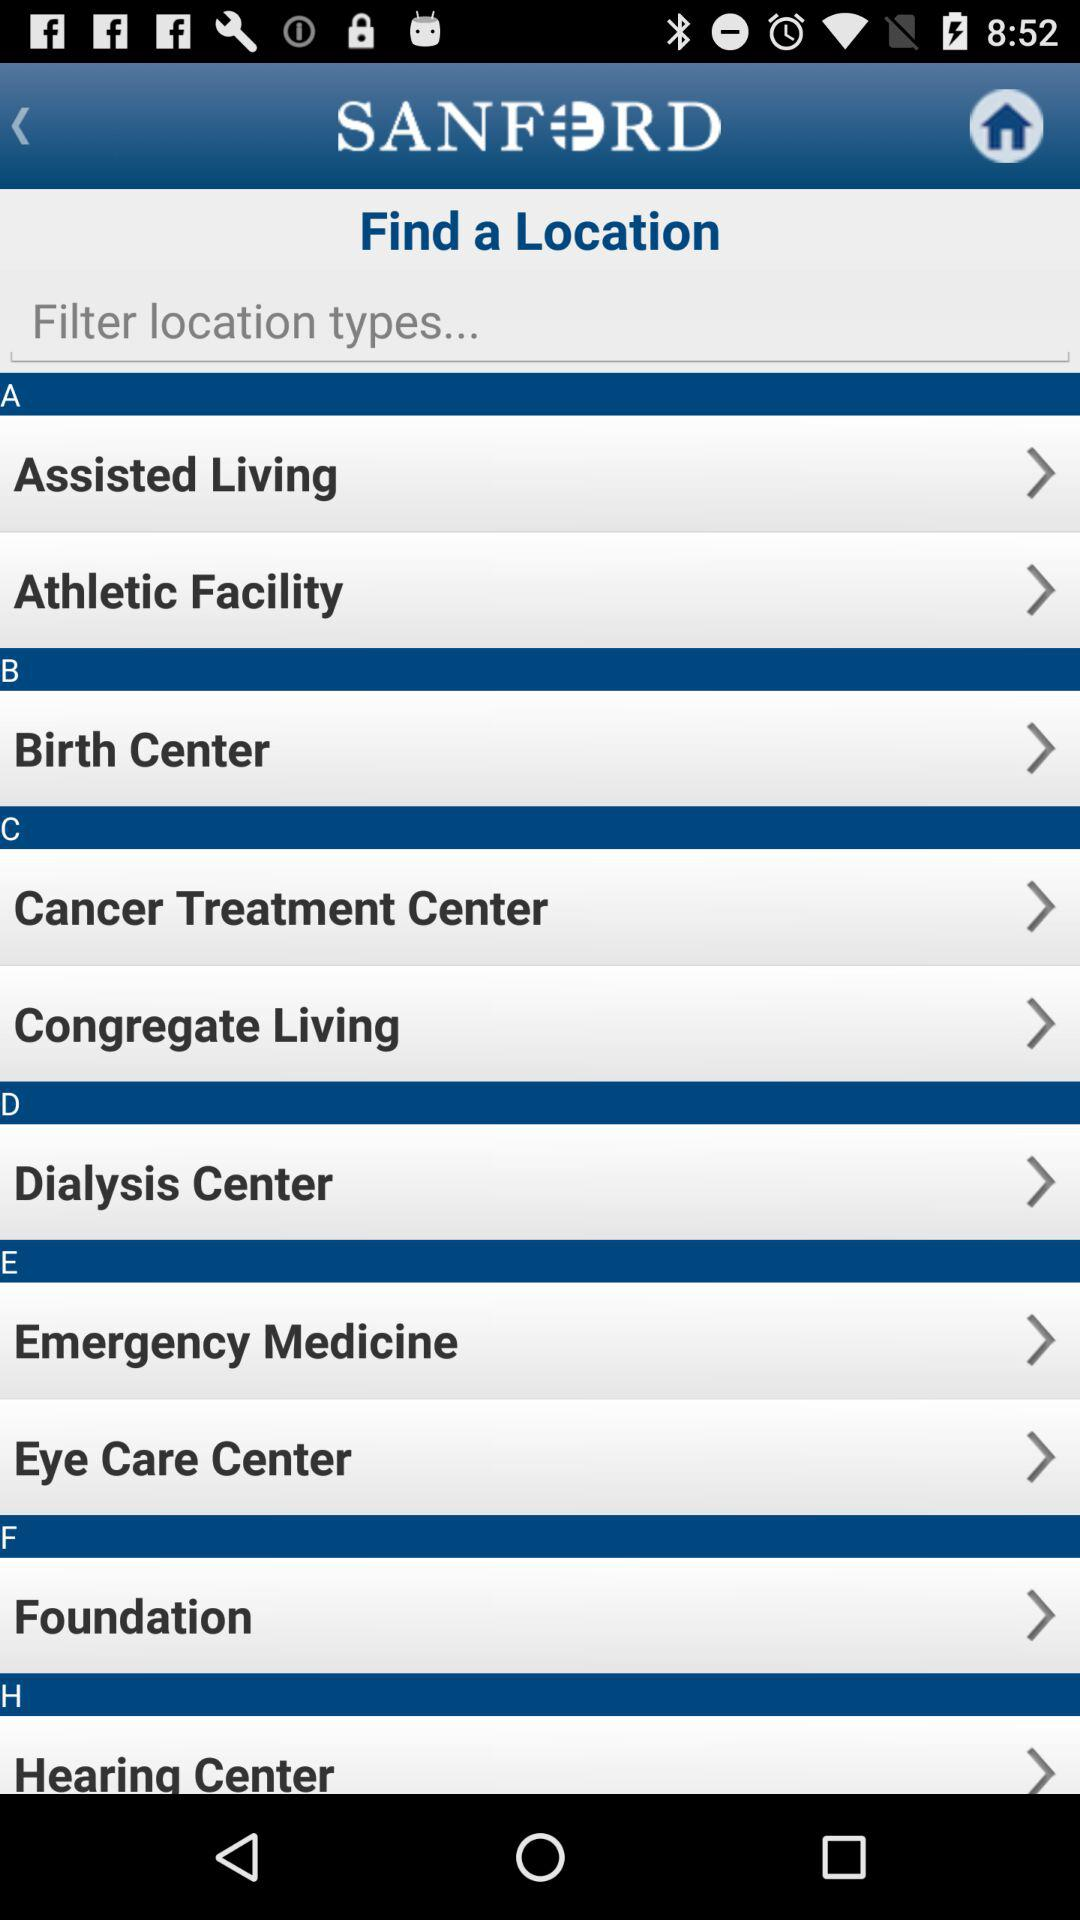What is the application name? The application name is "SANFORD". 